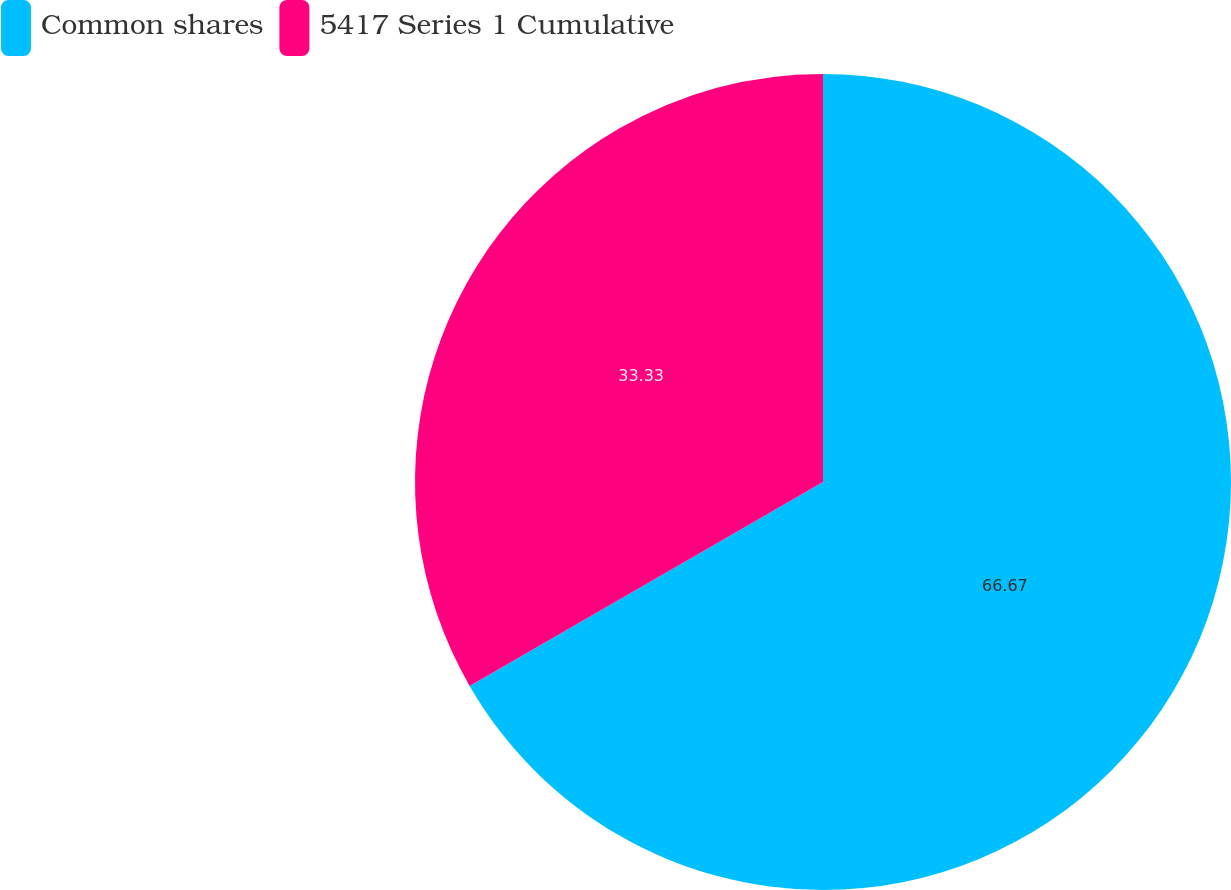Convert chart. <chart><loc_0><loc_0><loc_500><loc_500><pie_chart><fcel>Common shares<fcel>5417 Series 1 Cumulative<nl><fcel>66.67%<fcel>33.33%<nl></chart> 